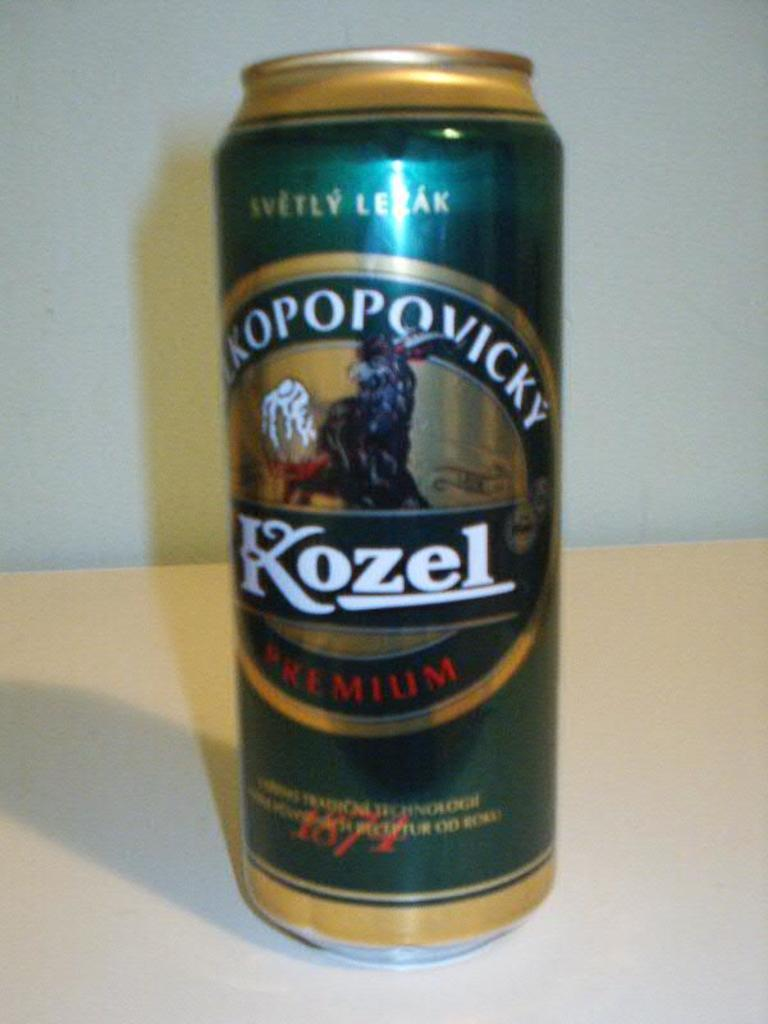<image>
Offer a succinct explanation of the picture presented. A can of Kozel beer has a strange creature on it. 